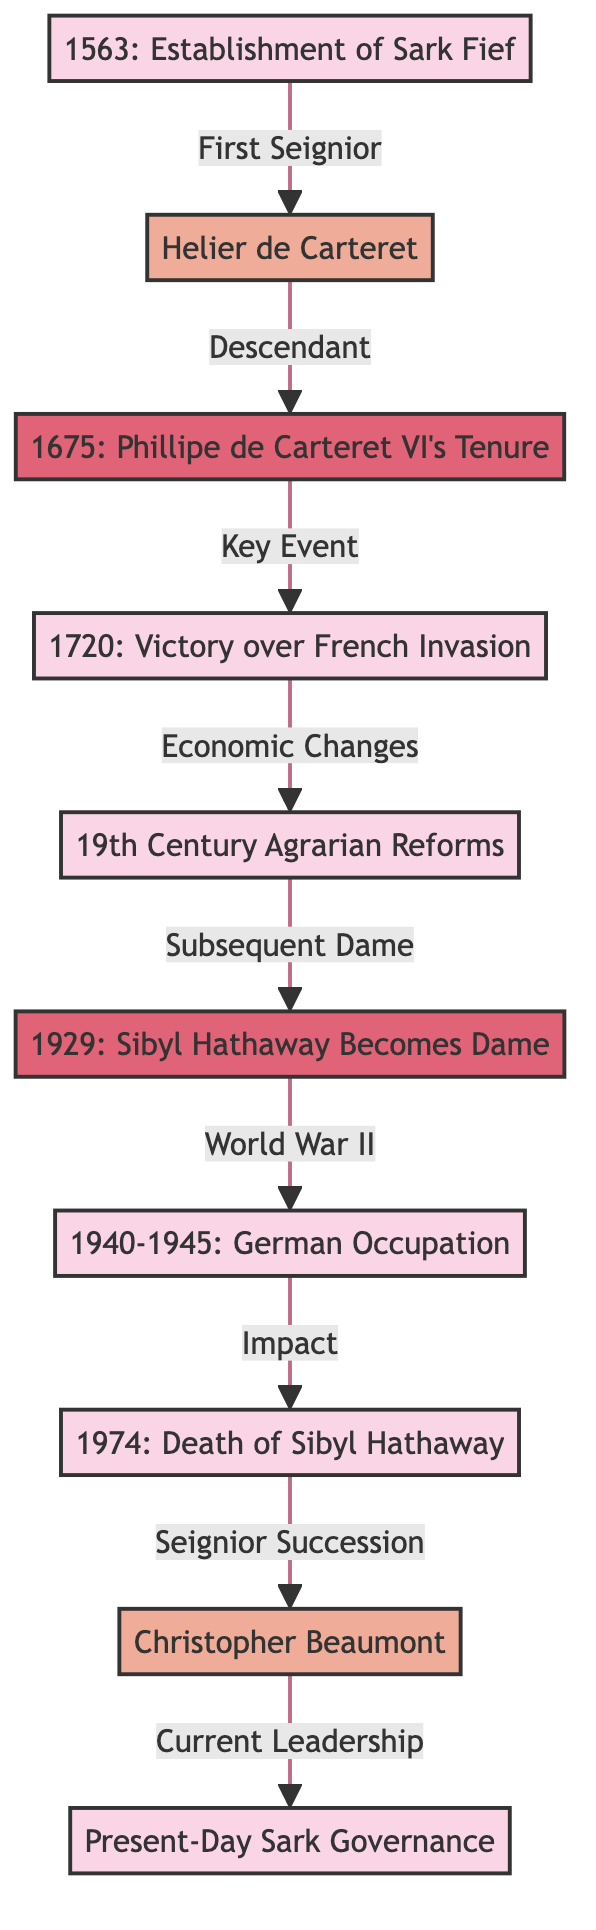What year did the establishment of Sark Fief occur? The diagram clearly states that the establishment of Sark Fief took place in 1563. This information is presented as the first node in the flowchart.
Answer: 1563 Who was the first Seignior of Sark? According to the diagram, Helier de Carteret is labeled as the first Seignior of Sark, appearing as a person node directly after the establishment event.
Answer: Helier de Carteret What event is linked to Phillipe de Carteret VI? The diagram indicates that Phillipe de Carteret VI's tenure is connected to the key event in 1720, which is the victory over the French invasion. This is illustrated by an arrow pointing to the next event node.
Answer: Victory over French Invasion What significant event happened between 1940 and 1945? The diagram explicitly states that the German occupation occurred during this time period, indicating a critical historical event that arose from World War II shown in the timeline.
Answer: German Occupation How did the agrarian reforms relate to Sibyl Hathaway? The agrarian reforms, noted in the 19th century, set the stage for the subsequent appointment of Sibyl Hathaway as Dame in 1929. This connection is made clear through the flow direction leading to her tenure.
Answer: Subsequent Dame Who succeeded Sibyl Hathaway? The diagram elaborates that after the death of Sibyl Hathaway in 1974, the succession was taken over by Christopher Beaumont, as indicated by the connection labeled "Seignior Succession."
Answer: Christopher Beaumont What is the final event depicted in the timeline? The final event in the diagram is labeled as "Present-Day Sark Governance," which illustrates the current status of governance in Sark following the historical events represented earlier in the flowchart.
Answer: Present-Day Sark Governance Count the total number of events depicted in the diagram. The diagram includes a total of five distinct events. These events are identified and counted from the nodes marked with "event," showcasing the historical milestones in Sark's timeline.
Answer: 5 What year did Sibyl Hathaway become Dame? The very specific year mentioned in the diagram for Sibyl Hathaway becoming Dame is 1929. This information is shown in the timeline of her tenure and position.
Answer: 1929 